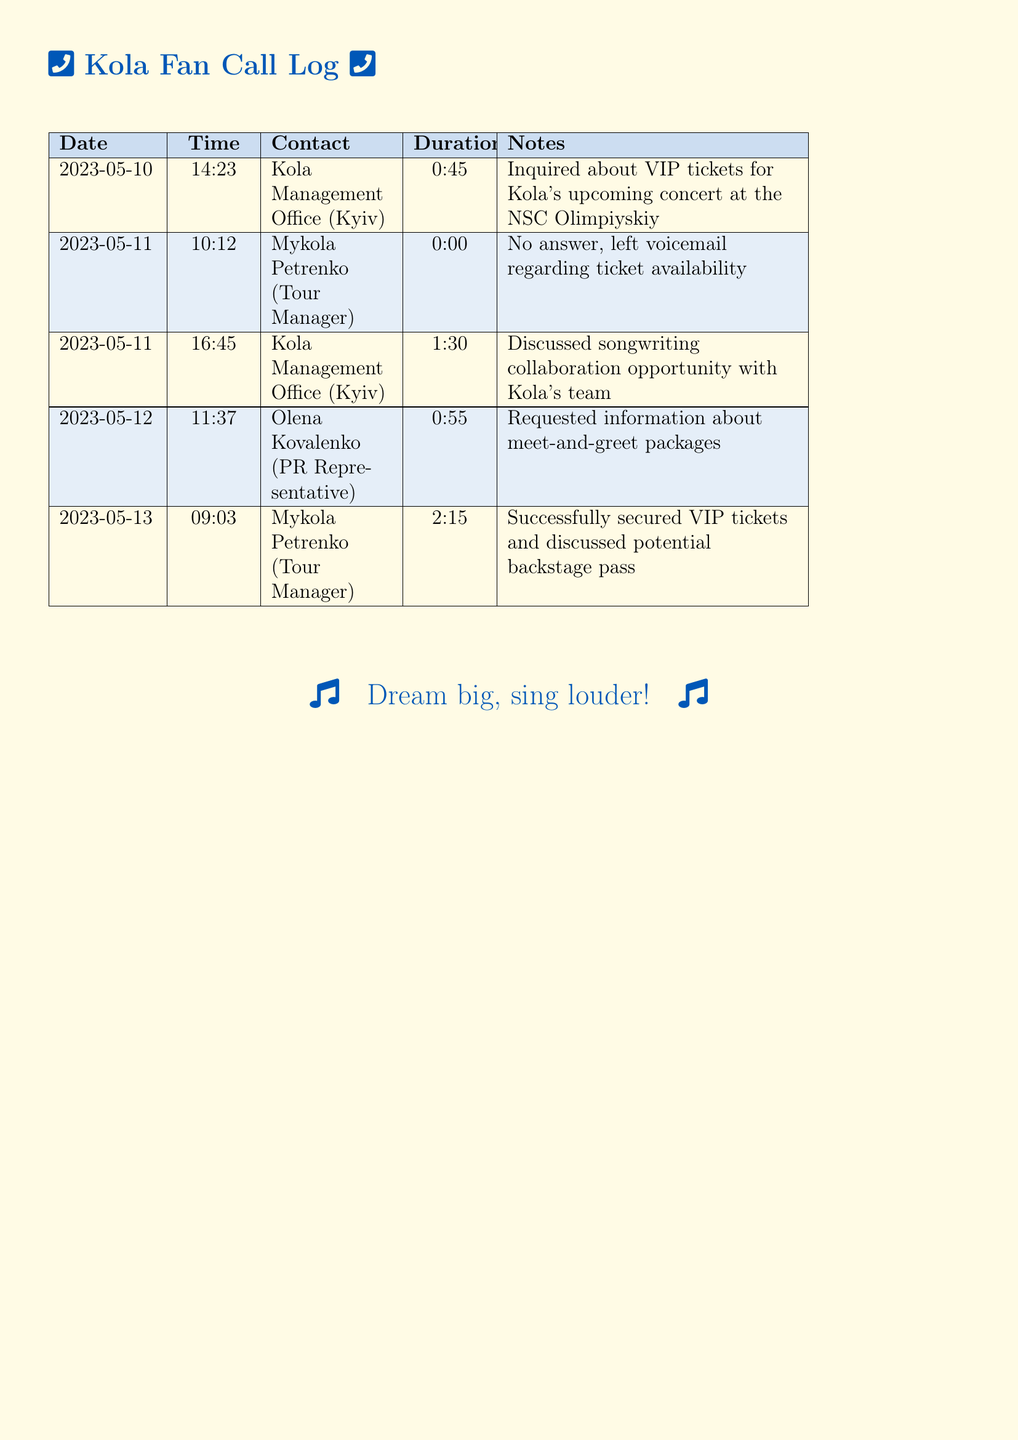What date was the first call made? The first call was made on May 10, 2023, as indicated in the document.
Answer: May 10, 2023 Who did Kola's management office contact on May 11, 2023? The contact on May 11, 2023, was Mykola Petrenko, noted as the Tour Manager.
Answer: Mykola Petrenko What was the duration of the call with Olena Kovalenko? The duration of the call with Olena Kovalenko is recorded as 0:55 minutes in the document.
Answer: 0:55 How many attempts were made to reach Kola’s management team? There were a total of four attempts made to contact Kola's management team as per the records detailed in the document.
Answer: Four What information was discussed during the call on May 13, 2023? The call on May 13, 2023, included a discussion about successfully securing VIP tickets and a potential backstage pass.
Answer: VIP tickets and backstage pass Which representative provided information about meet-and-greet packages? Olena Kovalenko, the PR Representative, provided information about meet-and-greet packages.
Answer: Olena Kovalenko What was the longest call duration recorded? The longest call duration recorded was 2:15 minutes during the discussion with Mykola Petrenko on May 13, 2023.
Answer: 2:15 Was a voicemail left during any of the calls? Yes, a voicemail was left when there was no answer during the call to Mykola Petrenko.
Answer: Yes What was discussed in the call on May 11, 2023, at 16:45? The call on May 11, 2023, at 16:45 discussed a songwriting collaboration opportunity with Kola's team.
Answer: Songwriting collaboration 